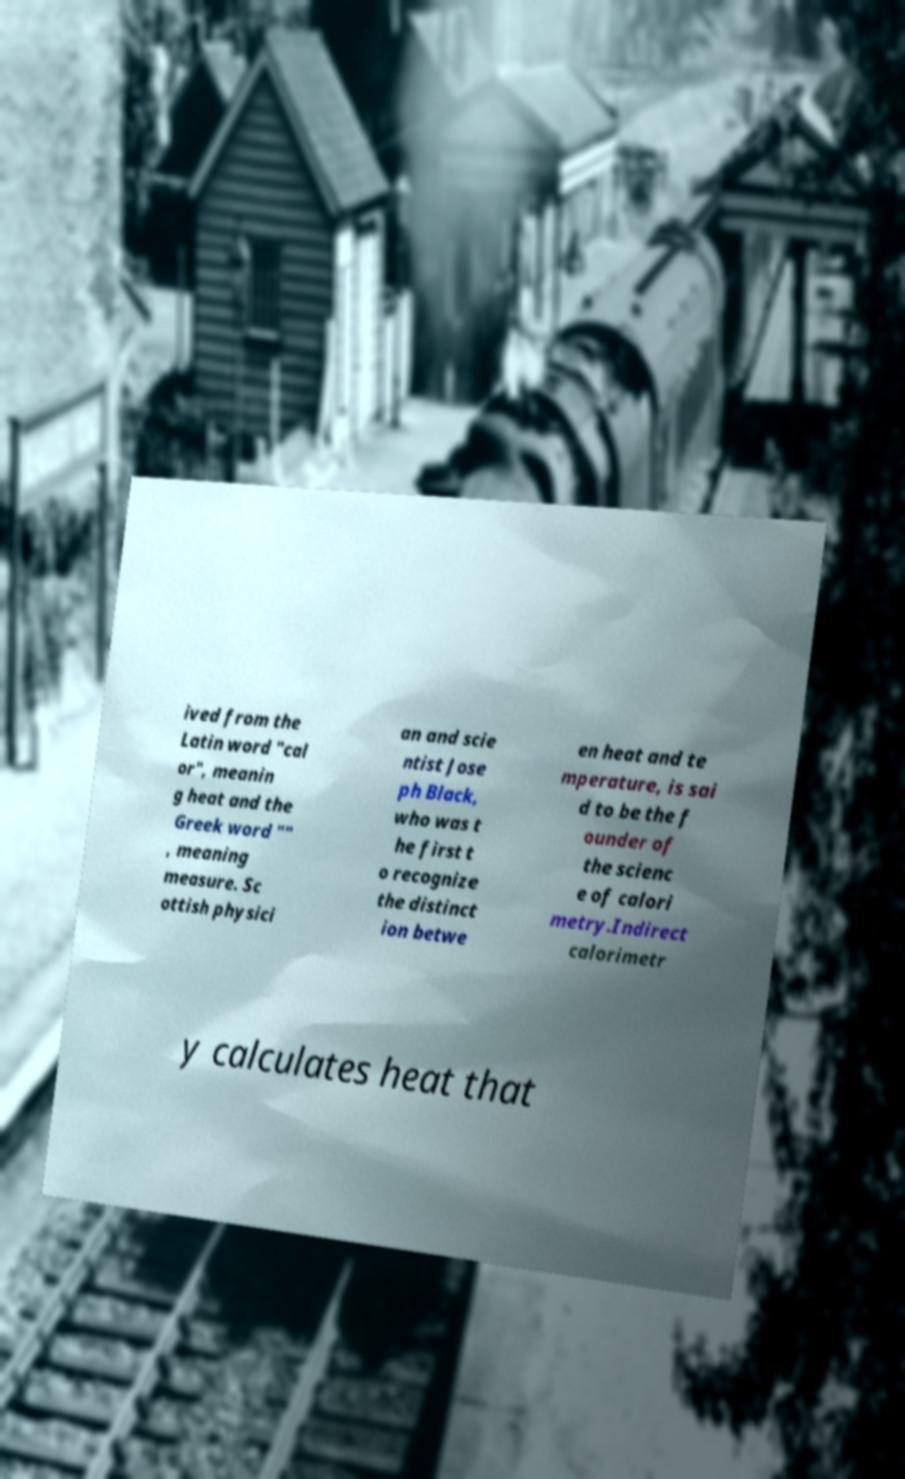There's text embedded in this image that I need extracted. Can you transcribe it verbatim? ived from the Latin word "cal or", meanin g heat and the Greek word "" , meaning measure. Sc ottish physici an and scie ntist Jose ph Black, who was t he first t o recognize the distinct ion betwe en heat and te mperature, is sai d to be the f ounder of the scienc e of calori metry.Indirect calorimetr y calculates heat that 